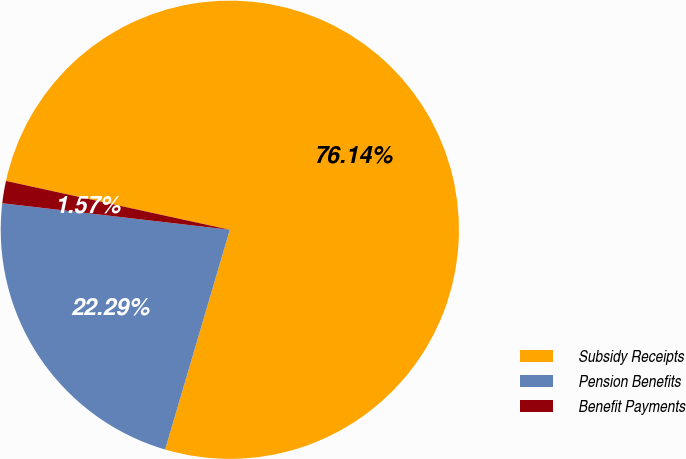Convert chart. <chart><loc_0><loc_0><loc_500><loc_500><pie_chart><fcel>Subsidy Receipts<fcel>Pension Benefits<fcel>Benefit Payments<nl><fcel>76.14%<fcel>22.29%<fcel>1.57%<nl></chart> 